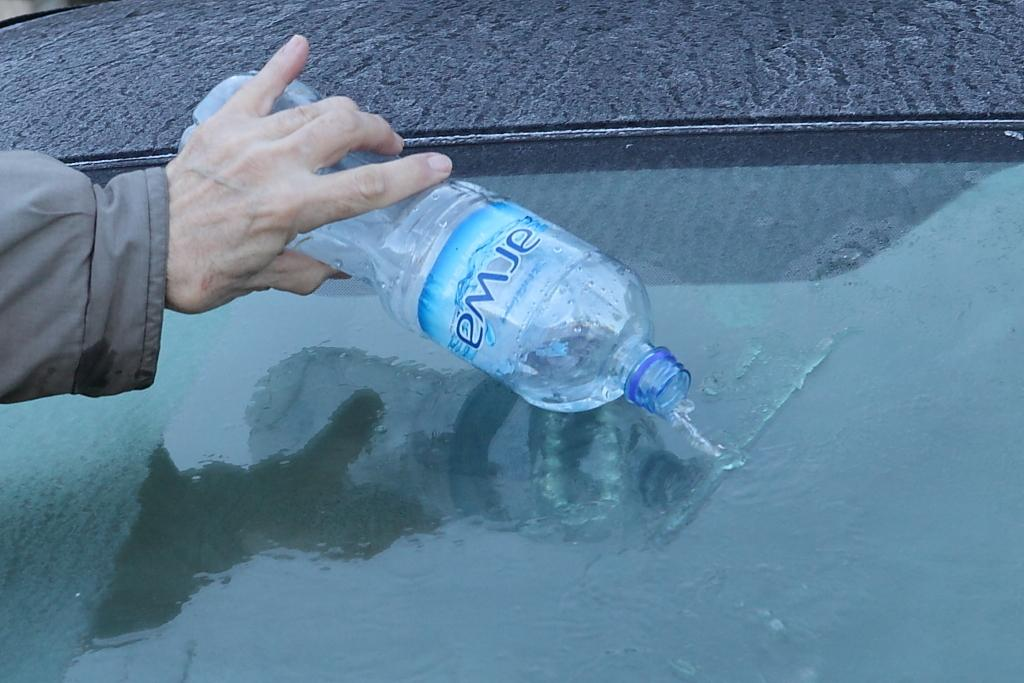What object is being held by the person in the image? There is a bottle in the image, and a person is holding it. What is the person doing with the bottle? The person is throwing water from the bottle onto the ground. How many trees can be seen in the image? There is no mention of trees in the image, so we cannot determine the number of trees present. 